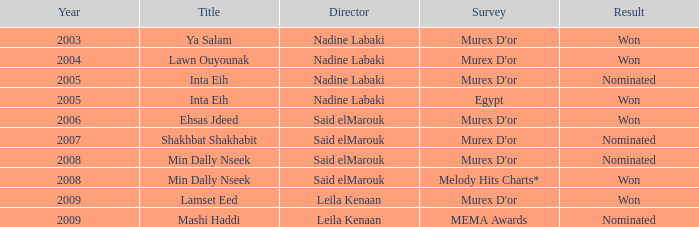Give me the full table as a dictionary. {'header': ['Year', 'Title', 'Director', 'Survey', 'Result'], 'rows': [['2003', 'Ya Salam', 'Nadine Labaki', "Murex D'or", 'Won'], ['2004', 'Lawn Ouyounak', 'Nadine Labaki', "Murex D'or", 'Won'], ['2005', 'Inta Eih', 'Nadine Labaki', "Murex D'or", 'Nominated'], ['2005', 'Inta Eih', 'Nadine Labaki', 'Egypt', 'Won'], ['2006', 'Ehsas Jdeed', 'Said elMarouk', "Murex D'or", 'Won'], ['2007', 'Shakhbat Shakhabit', 'Said elMarouk', "Murex D'or", 'Nominated'], ['2008', 'Min Dally Nseek', 'Said elMarouk', "Murex D'or", 'Nominated'], ['2008', 'Min Dally Nseek', 'Said elMarouk', 'Melody Hits Charts*', 'Won'], ['2009', 'Lamset Eed', 'Leila Kenaan', "Murex D'or", 'Won'], ['2009', 'Mashi Haddi', 'Leila Kenaan', 'MEMA Awards', 'Nominated']]} Who is the director possessing the min dally nseek title, and succeeded? Said elMarouk. 